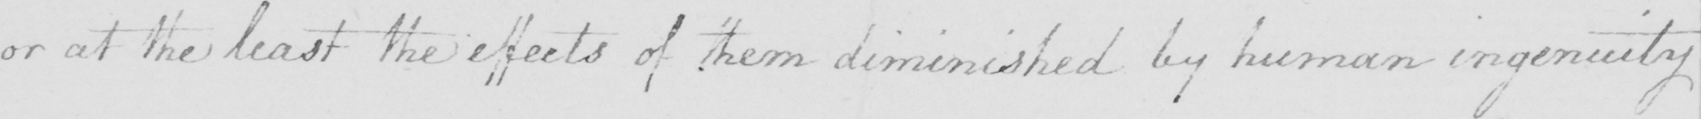Please provide the text content of this handwritten line. or at the least the effects of them diminished by human ingenuity 